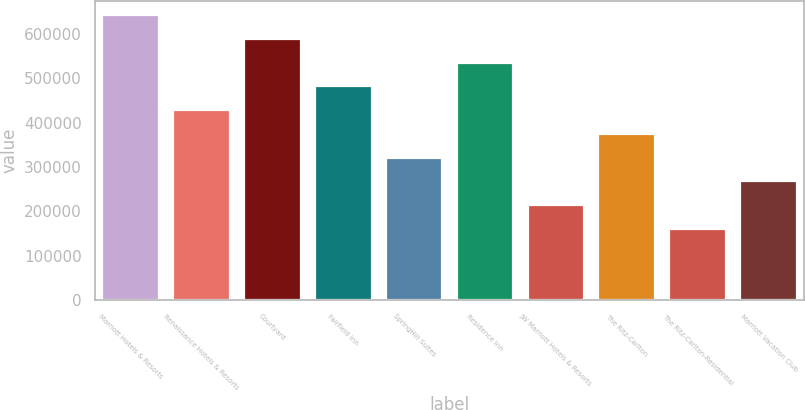<chart> <loc_0><loc_0><loc_500><loc_500><bar_chart><fcel>Marriott Hotels & Resorts<fcel>Renaissance Hotels & Resorts<fcel>Courtyard<fcel>Fairfield Inn<fcel>SpringHill Suites<fcel>Residence Inn<fcel>JW Marriott Hotels & Resorts<fcel>The Ritz-Carlton<fcel>The Ritz-Carlton-Residential<fcel>Marriott Vacation Club<nl><fcel>642083<fcel>428103<fcel>588588<fcel>481598<fcel>321113<fcel>535093<fcel>214124<fcel>374608<fcel>160629<fcel>267618<nl></chart> 